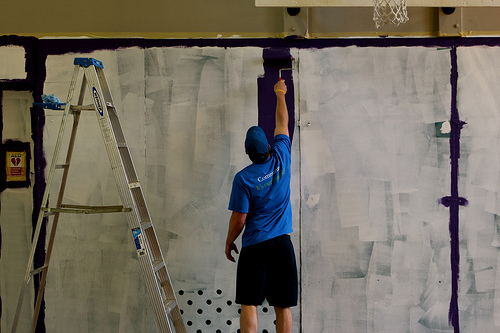<image>
Can you confirm if the man is in front of the wall? Yes. The man is positioned in front of the wall, appearing closer to the camera viewpoint. 